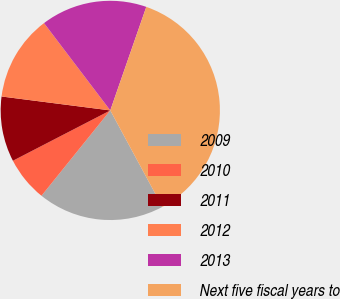Convert chart to OTSL. <chart><loc_0><loc_0><loc_500><loc_500><pie_chart><fcel>2009<fcel>2010<fcel>2011<fcel>2012<fcel>2013<fcel>Next five fiscal years to<nl><fcel>18.68%<fcel>6.61%<fcel>9.62%<fcel>12.64%<fcel>15.66%<fcel>36.79%<nl></chart> 